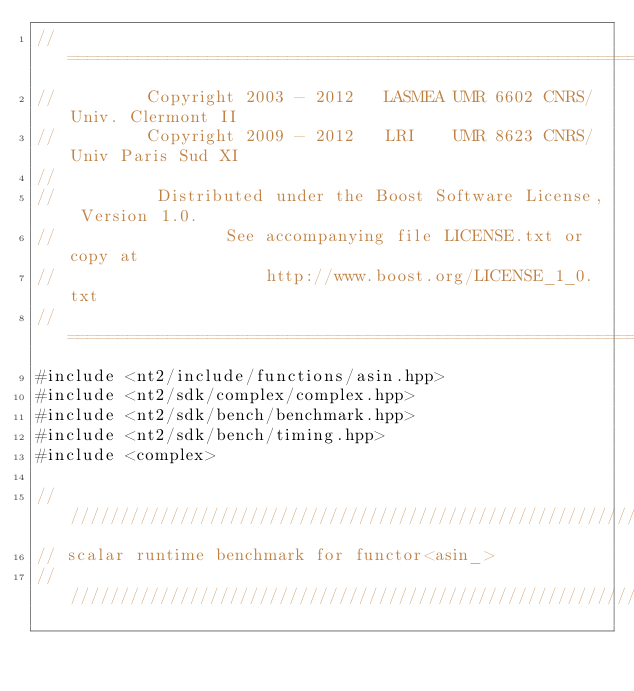Convert code to text. <code><loc_0><loc_0><loc_500><loc_500><_C++_>//==============================================================================
//         Copyright 2003 - 2012   LASMEA UMR 6602 CNRS/Univ. Clermont II
//         Copyright 2009 - 2012   LRI    UMR 8623 CNRS/Univ Paris Sud XI
//
//          Distributed under the Boost Software License, Version 1.0.
//                 See accompanying file LICENSE.txt or copy at
//                     http://www.boost.org/LICENSE_1_0.txt
//==============================================================================
#include <nt2/include/functions/asin.hpp>
#include <nt2/sdk/complex/complex.hpp>
#include <nt2/sdk/bench/benchmark.hpp>
#include <nt2/sdk/bench/timing.hpp>
#include <complex>

//////////////////////////////////////////////////////////////////////////////
// scalar runtime benchmark for functor<asin_>
//////////////////////////////////////////////////////////////////////////////</code> 